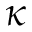<formula> <loc_0><loc_0><loc_500><loc_500>\kappa</formula> 